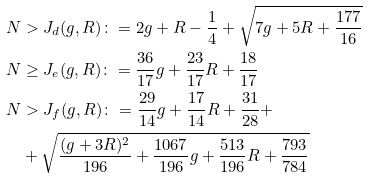<formula> <loc_0><loc_0><loc_500><loc_500>N & > J _ { d } ( g , R ) \colon = 2 g + R - \frac { 1 } { 4 } + \sqrt { 7 g + 5 R + \frac { 1 7 7 } { 1 6 } } \\ N & \geq J _ { e } ( g , R ) \colon = \frac { 3 6 } { 1 7 } g + \frac { 2 3 } { 1 7 } R + \frac { 1 8 } { 1 7 } \\ N & > J _ { f } ( g , R ) \colon = \frac { 2 9 } { 1 4 } g + \frac { 1 7 } { 1 4 } R + \frac { 3 1 } { 2 8 } + \\ & + \sqrt { \frac { ( g + 3 R ) ^ { 2 } } { 1 9 6 } + \frac { 1 0 6 7 } { 1 9 6 } g + \frac { 5 1 3 } { 1 9 6 } R + \frac { 7 9 3 } { 7 8 4 } }</formula> 